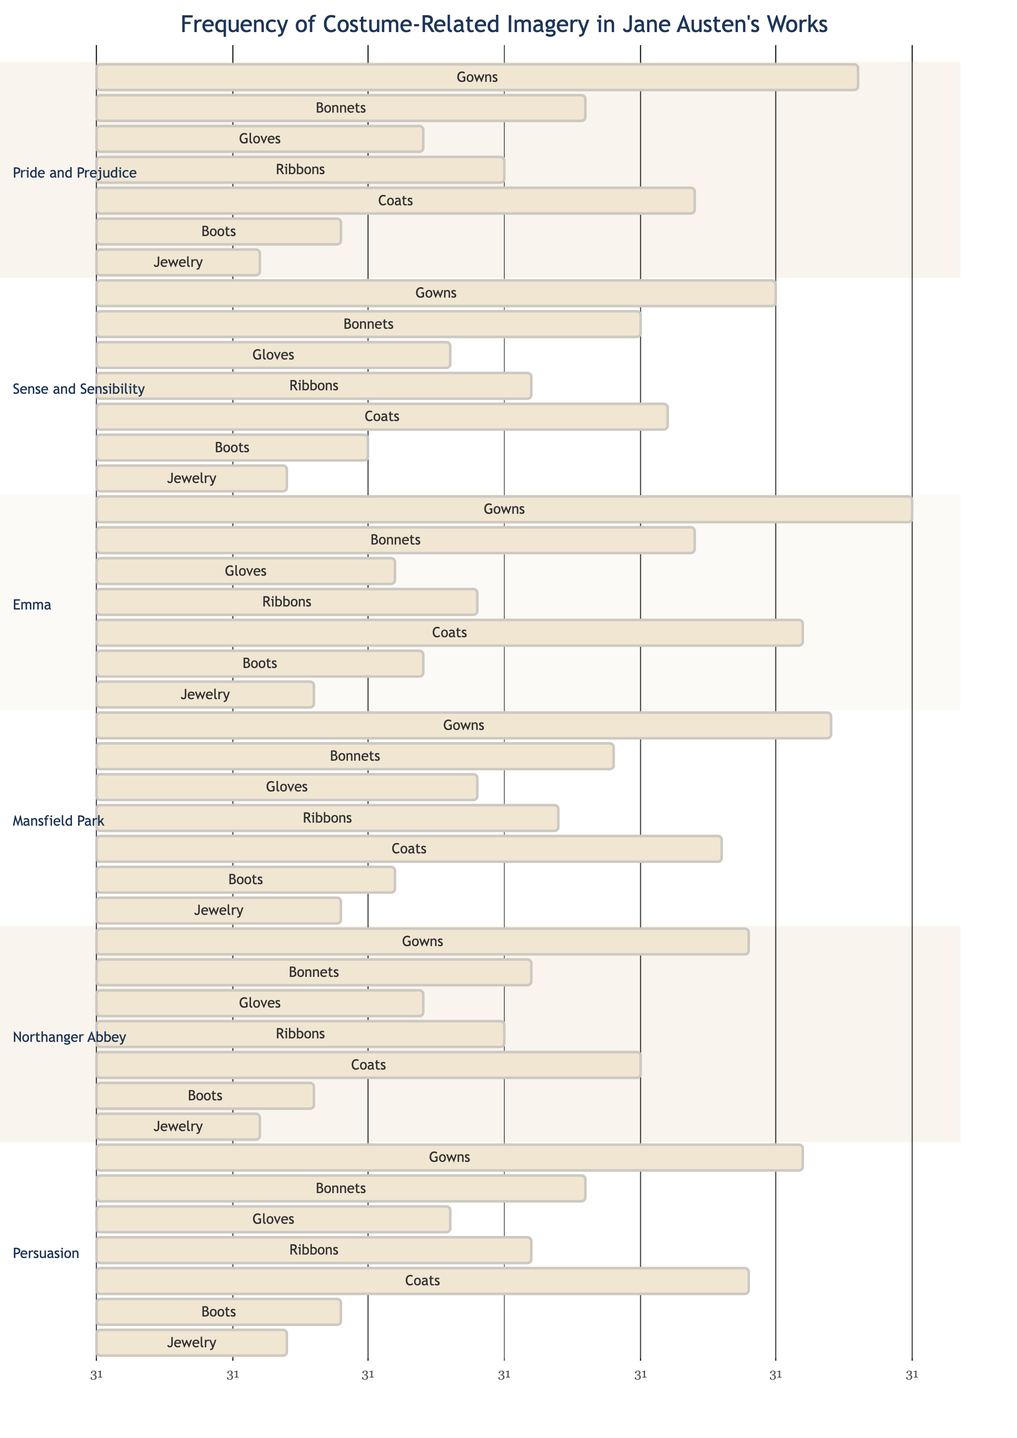What is the highest frequency of gown imagery in Jane Austen's novels? The histogram shows that "Emma" has the highest frequency of gown imagery with a count of 30.
Answer: 30 In which novel are bonnets mentioned the least frequently? By examining the counts of bonnets across all novels, "Northanger Abbey" has the least frequency with 16 mentions.
Answer: 16 How many different types of garments and accessories are represented in the diagram? The diagram lists 7 different types of garments and accessories: Gowns, Bonnets, Gloves, Ribbons, Coats, Boots, and Jewelry.
Answer: 7 Which novel has the highest frequency of coats? Upon reviewing the frequencies for coats, "Emma" has the highest count with 26 mentions.
Answer: 26 What is the total frequency of glove imagery in "Pride and Prejudice" and "Sense and Sensibility"? Adding the glove counts from both novels, "Pride and Prejudice" has 12 and "Sense and Sensibility" has 13, resulting in a total of 25.
Answer: 25 Which type of garment has a frequency of 9 across all novels? The diagram indicates that "Boots" have a frequency of 9 mentions, specifically in "Pride and Prejudice."
Answer: Boots In which novel do ribbons have a frequency of 15? The histogram shows that "Northanger Abbey" mentions ribbons 15 times.
Answer: Northanger Abbey Which novel ranked second in terms of gown imagery? Comparing the frequencies of gowns, "Pride and Prejudice" comes in second with 28 mentions.
Answer: Pride and Prejudice 